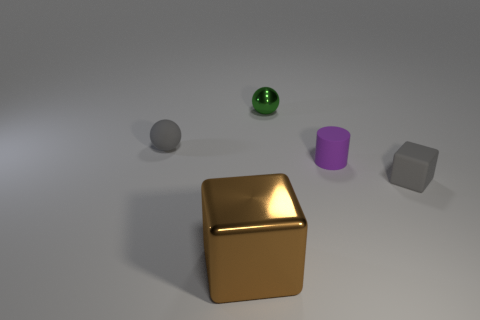The matte sphere that is the same color as the matte cube is what size?
Keep it short and to the point. Small. What material is the small object in front of the purple thing that is in front of the metal object that is behind the matte cube?
Keep it short and to the point. Rubber. What number of things are either gray matte blocks or red metal spheres?
Your answer should be very brief. 1. There is a tiny thing that is on the left side of the tiny metal object; does it have the same color as the object right of the purple thing?
Your response must be concise. Yes. What shape is the metallic object that is the same size as the rubber cylinder?
Make the answer very short. Sphere. How many objects are either small things in front of the green shiny thing or tiny gray rubber objects on the left side of the small gray rubber cube?
Your answer should be very brief. 3. Is the number of purple rubber objects less than the number of gray metal cylinders?
Offer a terse response. No. What is the material of the green thing that is the same size as the purple cylinder?
Your response must be concise. Metal. Do the metallic object that is in front of the gray rubber sphere and the gray thing to the right of the gray matte ball have the same size?
Offer a terse response. No. Are there any big brown objects that have the same material as the tiny green ball?
Offer a terse response. Yes. 